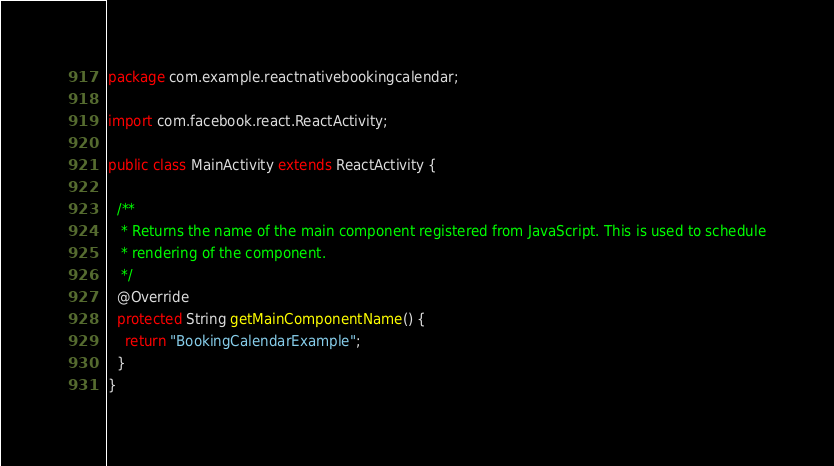Convert code to text. <code><loc_0><loc_0><loc_500><loc_500><_Java_>package com.example.reactnativebookingcalendar;

import com.facebook.react.ReactActivity;

public class MainActivity extends ReactActivity {

  /**
   * Returns the name of the main component registered from JavaScript. This is used to schedule
   * rendering of the component.
   */
  @Override
  protected String getMainComponentName() {
    return "BookingCalendarExample";
  }
}
</code> 